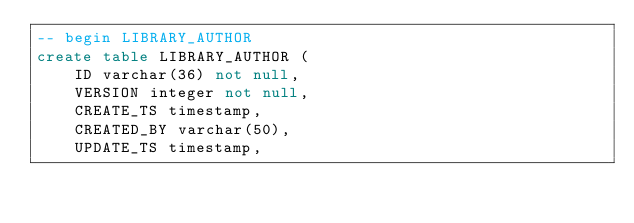<code> <loc_0><loc_0><loc_500><loc_500><_SQL_>-- begin LIBRARY_AUTHOR
create table LIBRARY_AUTHOR (
    ID varchar(36) not null,
    VERSION integer not null,
    CREATE_TS timestamp,
    CREATED_BY varchar(50),
    UPDATE_TS timestamp,</code> 